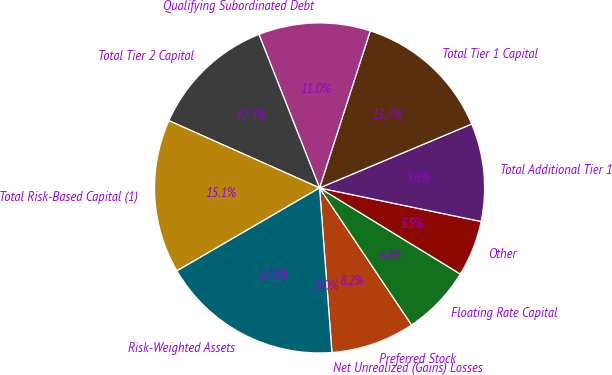Convert chart. <chart><loc_0><loc_0><loc_500><loc_500><pie_chart><fcel>Net Unrealized (Gains) Losses<fcel>Preferred Stock<fcel>Floating Rate Capital<fcel>Other<fcel>Total Additional Tier 1<fcel>Total Tier 1 Capital<fcel>Qualifying Subordinated Debt<fcel>Total Tier 2 Capital<fcel>Total Risk-Based Capital (1)<fcel>Risk-Weighted Assets<nl><fcel>0.0%<fcel>8.22%<fcel>6.85%<fcel>5.48%<fcel>9.59%<fcel>13.7%<fcel>10.96%<fcel>12.33%<fcel>15.07%<fcel>17.81%<nl></chart> 